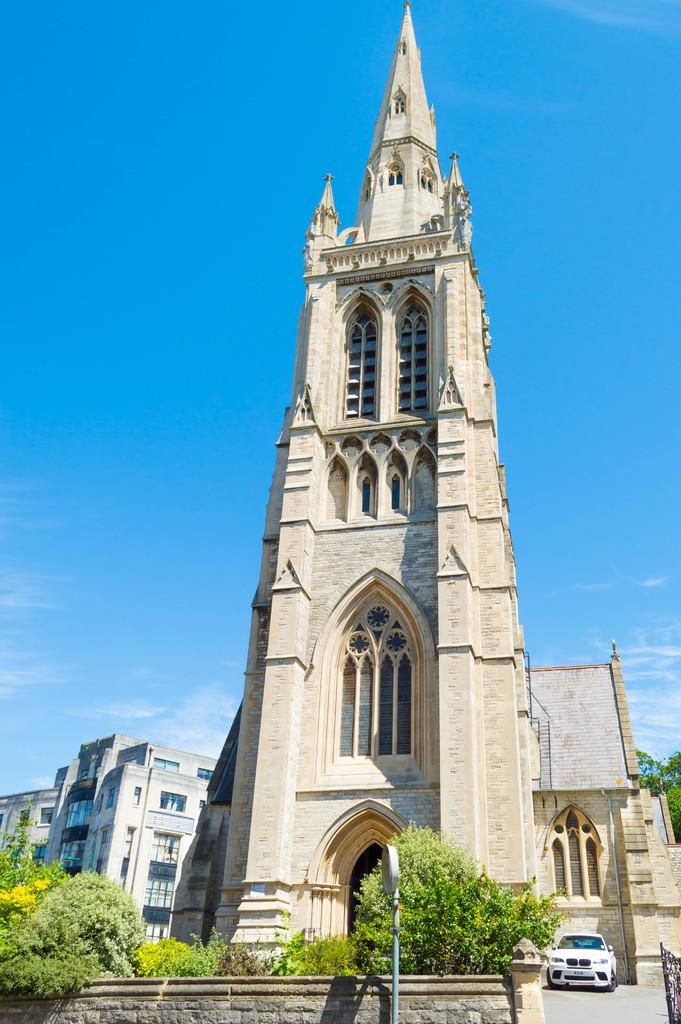What type of structure is visible in the image? There is a building in the image. What mode of transportation can be seen in the image? There is a car parked in the image. What type of vegetation is present in the image? There are plants and trees in the image. What can be seen in the backdrop of the image? There are other buildings and trees in the backdrop of the image. Can you tell me how many yaks are grazing in the image? There are no yaks present in the image. What type of muscle is being exercised by the trees in the image? Trees do not have muscles, so this question is not applicable to the image. 